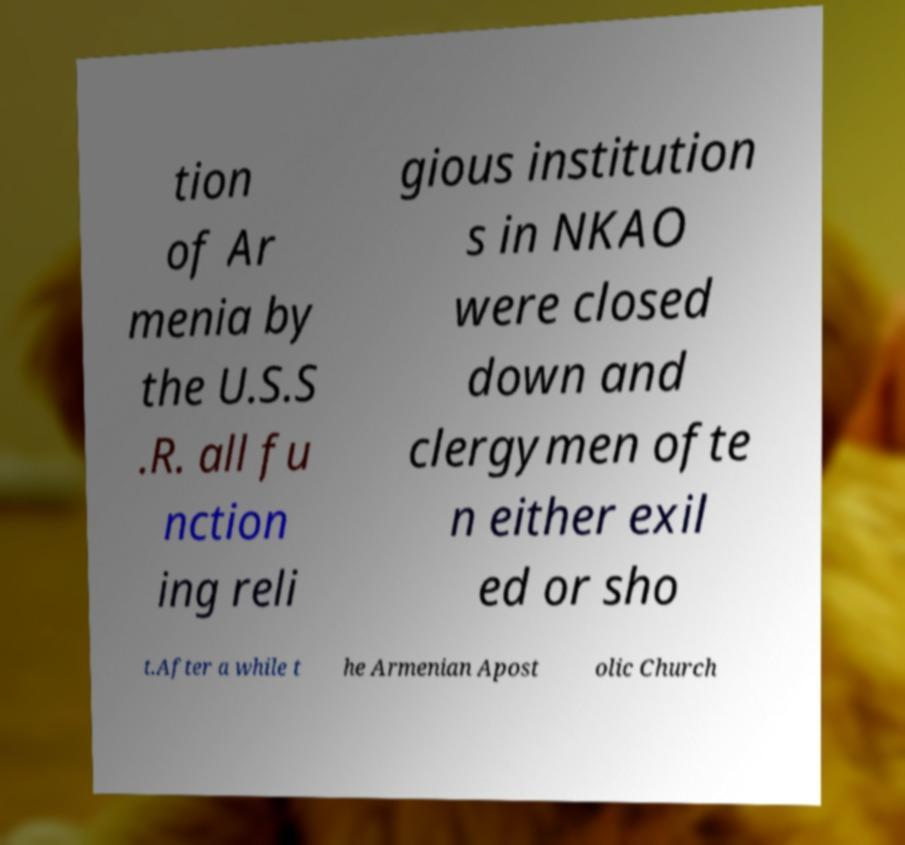Can you read and provide the text displayed in the image?This photo seems to have some interesting text. Can you extract and type it out for me? tion of Ar menia by the U.S.S .R. all fu nction ing reli gious institution s in NKAO were closed down and clergymen ofte n either exil ed or sho t.After a while t he Armenian Apost olic Church 